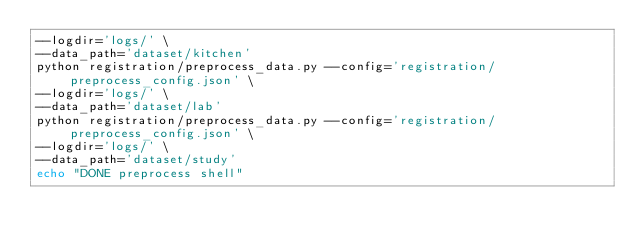Convert code to text. <code><loc_0><loc_0><loc_500><loc_500><_Bash_>--logdir='logs/' \
--data_path='dataset/kitchen'
python registration/preprocess_data.py --config='registration/preprocess_config.json' \
--logdir='logs/' \
--data_path='dataset/lab'
python registration/preprocess_data.py --config='registration/preprocess_config.json' \
--logdir='logs/' \
--data_path='dataset/study'
echo "DONE preprocess shell"</code> 